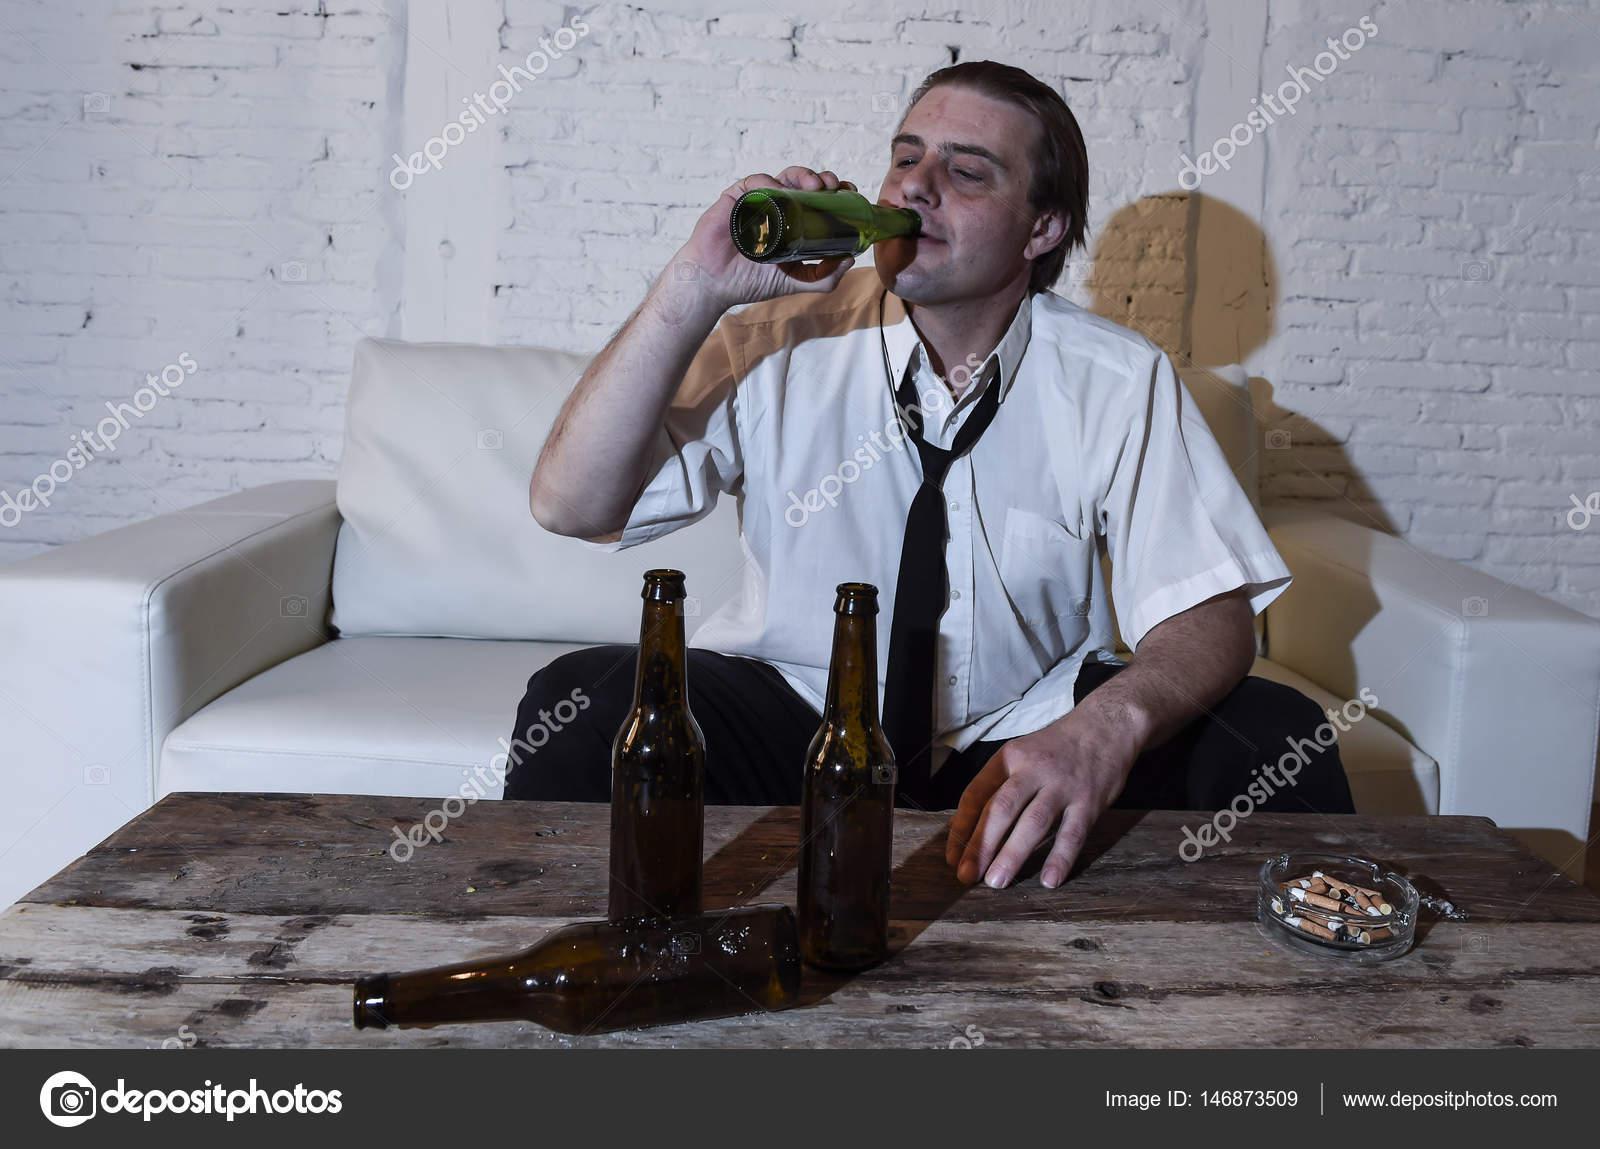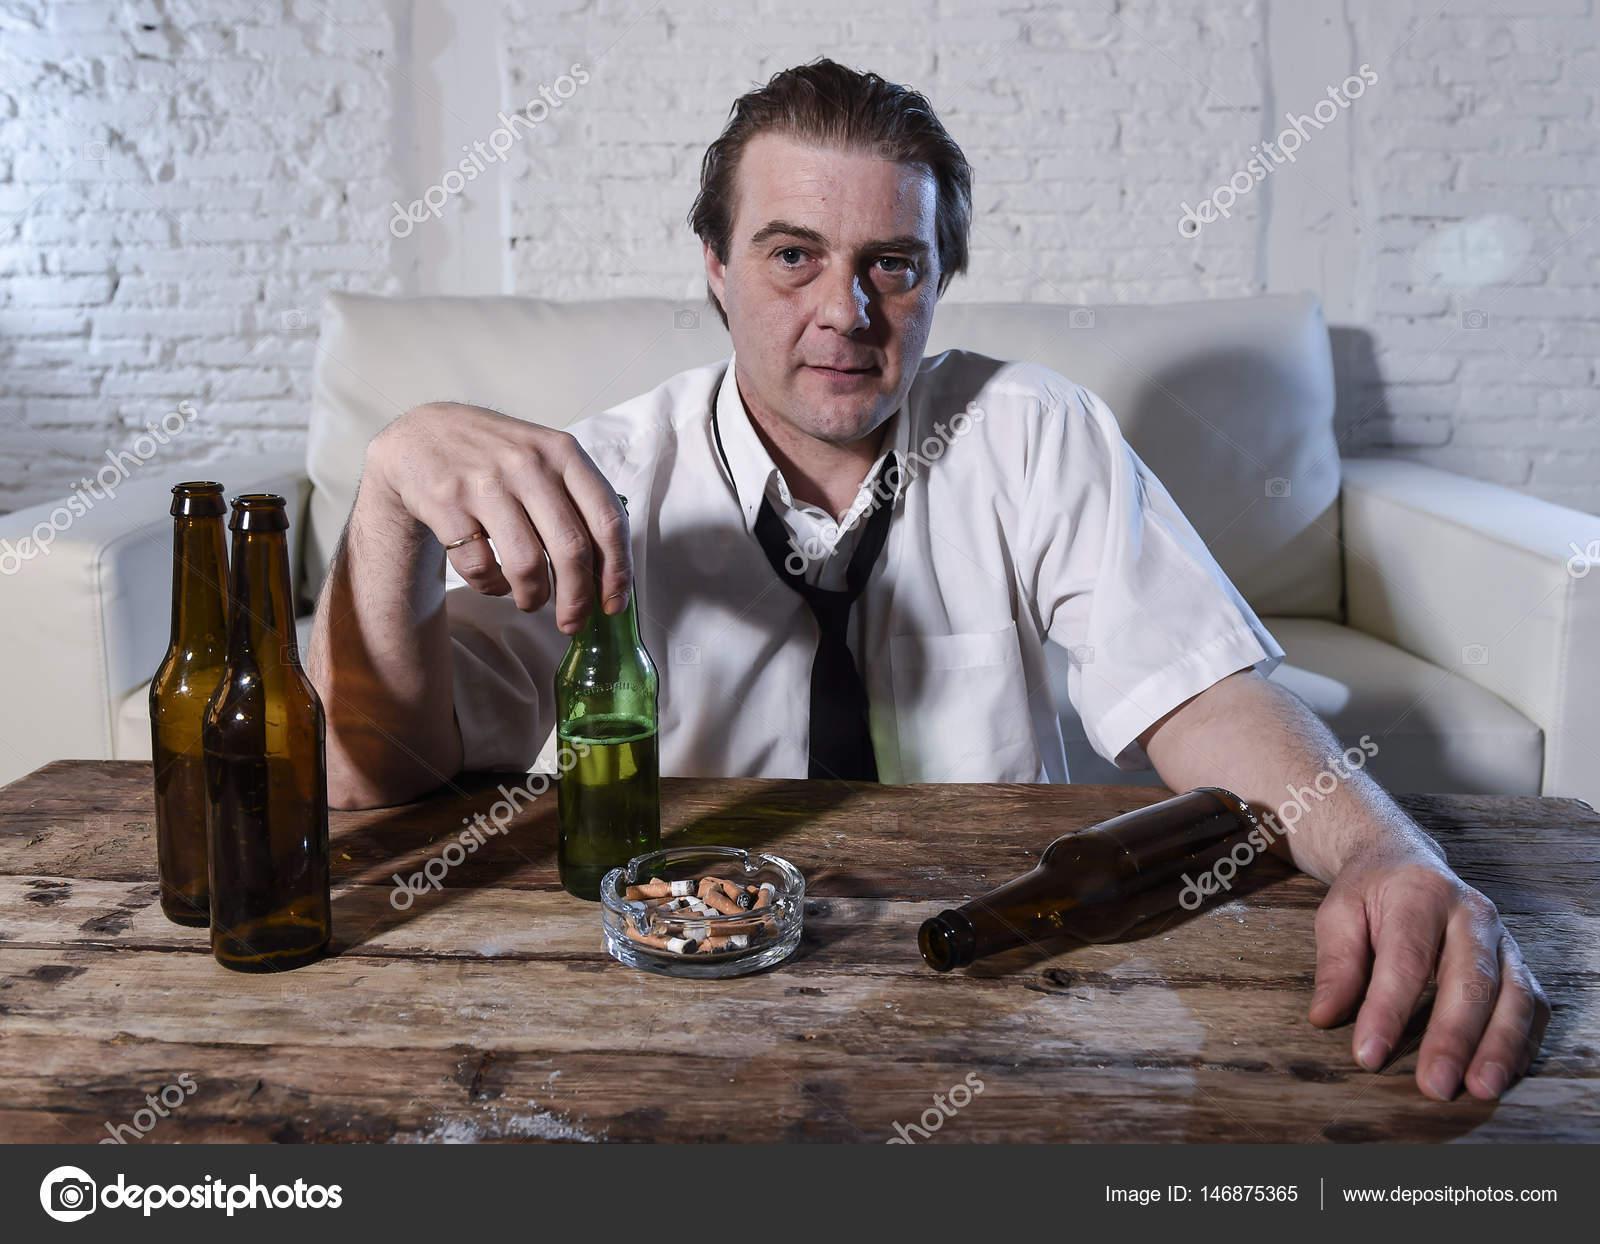The first image is the image on the left, the second image is the image on the right. For the images displayed, is the sentence "A man is holding a bottle to his mouth." factually correct? Answer yes or no. Yes. The first image is the image on the left, the second image is the image on the right. For the images shown, is this caption "The man is drinking his beer in the left image." true? Answer yes or no. Yes. 